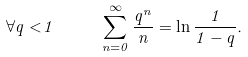<formula> <loc_0><loc_0><loc_500><loc_500>\forall q < 1 \quad \sum _ { n = 0 } ^ { \infty } \frac { q ^ { n } } { n } = \ln \frac { 1 } { 1 - q } .</formula> 